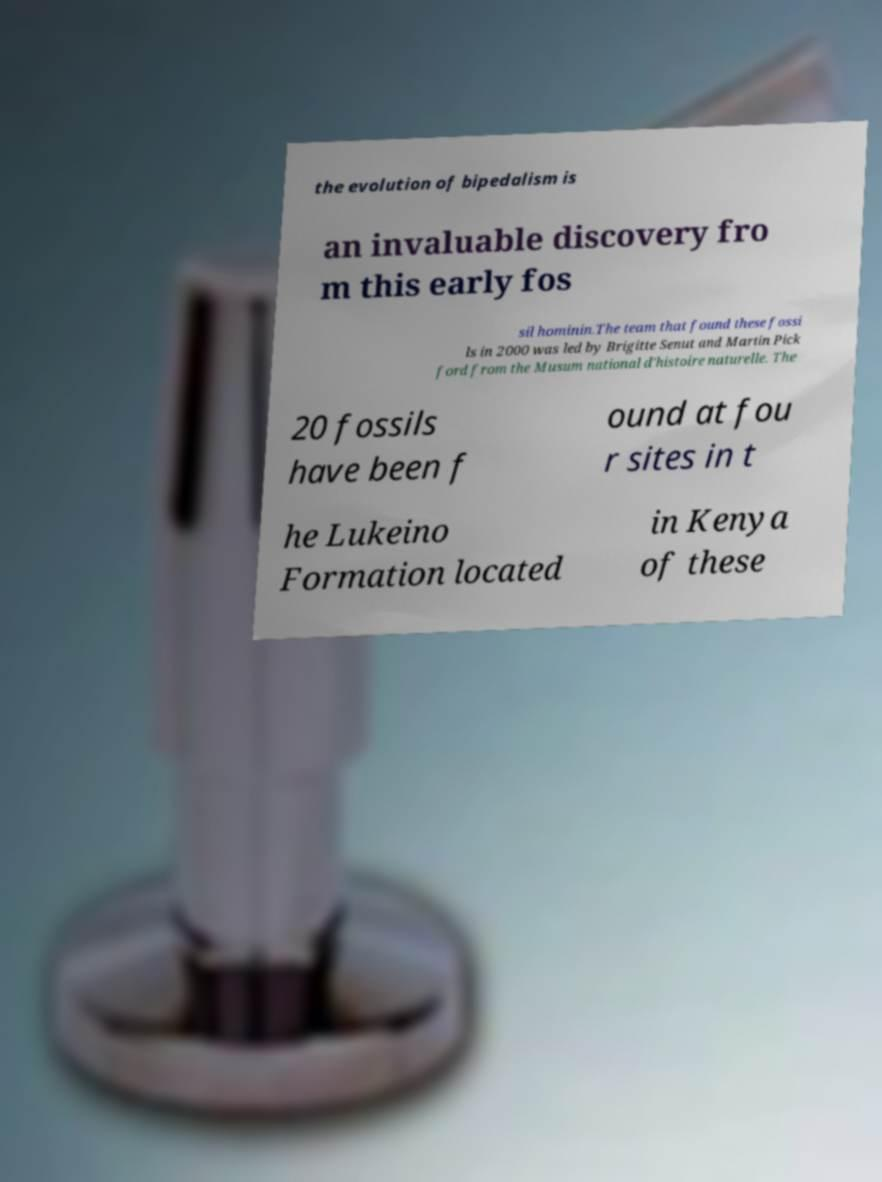Can you read and provide the text displayed in the image?This photo seems to have some interesting text. Can you extract and type it out for me? the evolution of bipedalism is an invaluable discovery fro m this early fos sil hominin.The team that found these fossi ls in 2000 was led by Brigitte Senut and Martin Pick ford from the Musum national d'histoire naturelle. The 20 fossils have been f ound at fou r sites in t he Lukeino Formation located in Kenya of these 